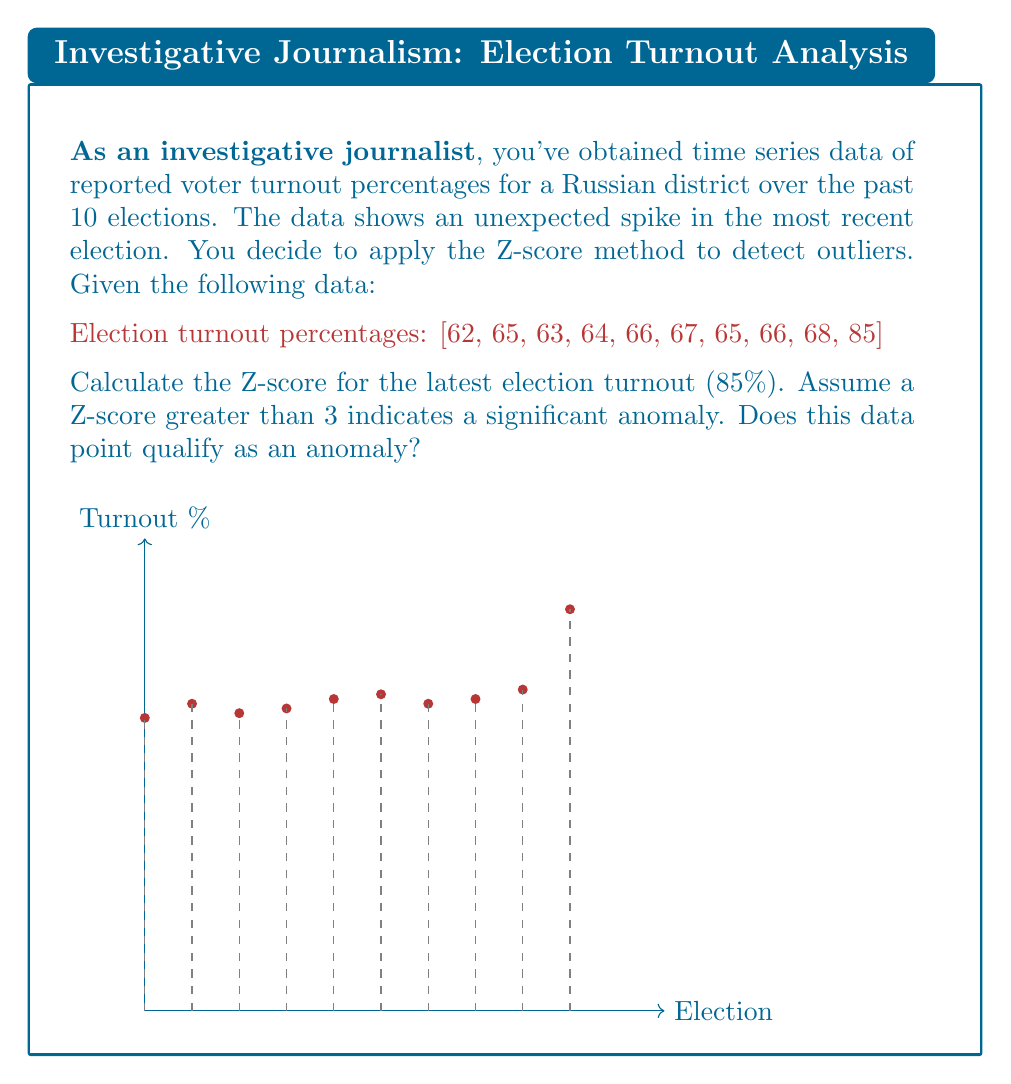Give your solution to this math problem. To determine if the latest election turnout is an anomaly using the Z-score method, we'll follow these steps:

1) Calculate the mean ($\mu$) of the turnout percentages:
   $$\mu = \frac{62 + 65 + 63 + 64 + 66 + 67 + 65 + 66 + 68 + 85}{10} = 67.1$$

2) Calculate the standard deviation ($\sigma$):
   $$\sigma = \sqrt{\frac{\sum_{i=1}^{n} (x_i - \mu)^2}{n}}$$
   where $x_i$ are the individual turnout percentages and $n = 10$.
   
   $$\sigma = \sqrt{\frac{(62-67.1)^2 + ... + (85-67.1)^2}{10}} \approx 6.64$$

3) Calculate the Z-score for the latest election (85%):
   $$Z = \frac{x - \mu}{\sigma} = \frac{85 - 67.1}{6.64} \approx 2.69$$

4) Compare the Z-score to the threshold:
   The calculated Z-score (2.69) is less than the threshold of 3.

Therefore, while the latest election turnout is notably higher than previous years, it does not qualify as a significant anomaly according to the Z-score method with a threshold of 3.
Answer: Z-score ≈ 2.69; Not a significant anomaly 